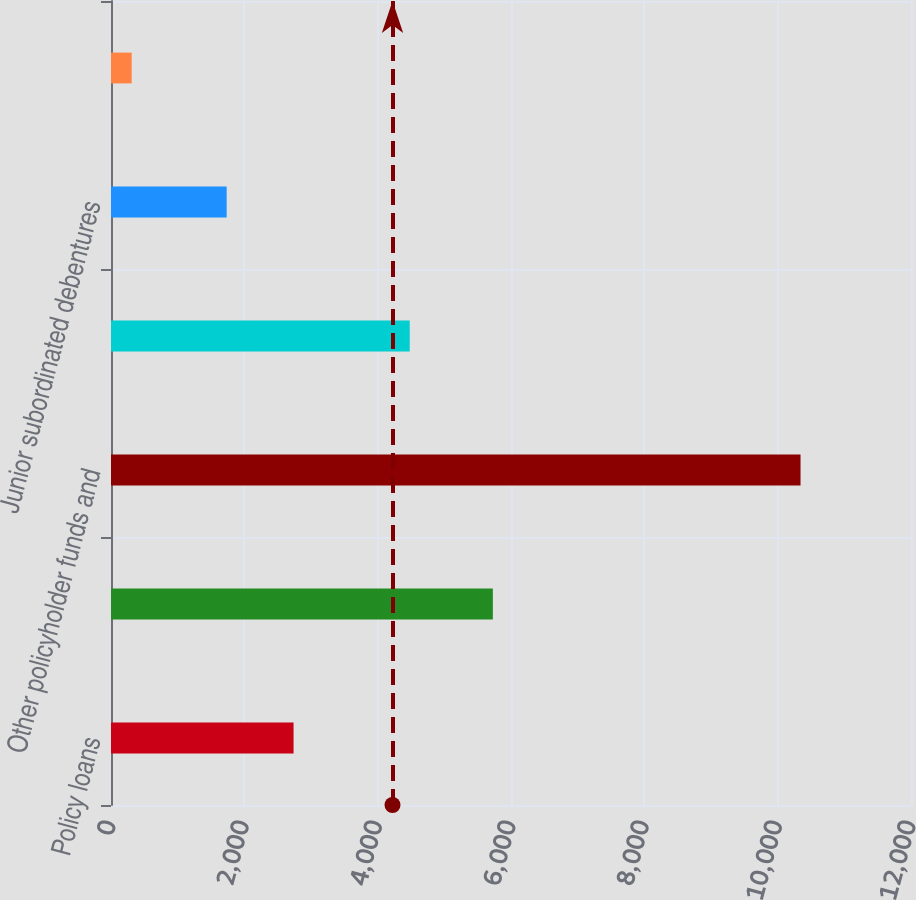Convert chart. <chart><loc_0><loc_0><loc_500><loc_500><bar_chart><fcel>Policy loans<fcel>Mortgage loans<fcel>Other policyholder funds and<fcel>Senior notes 2<fcel>Junior subordinated debentures<fcel>Consumer notes 3<nl><fcel>2738.3<fcel>5728<fcel>10343<fcel>4481<fcel>1735<fcel>310<nl></chart> 